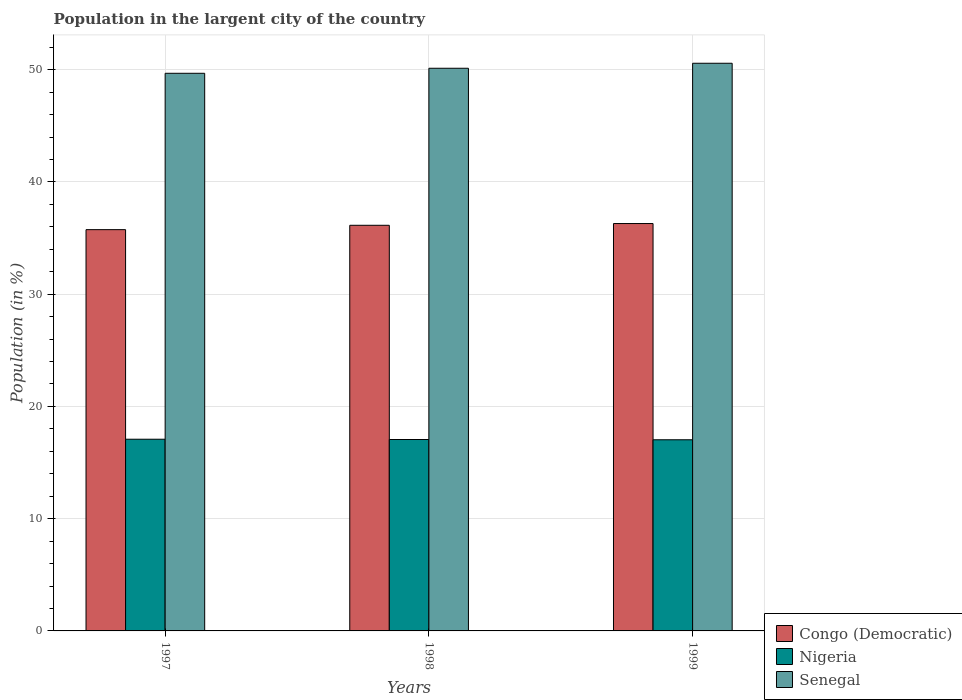Are the number of bars on each tick of the X-axis equal?
Offer a terse response. Yes. How many bars are there on the 3rd tick from the left?
Provide a short and direct response. 3. How many bars are there on the 3rd tick from the right?
Your answer should be compact. 3. What is the label of the 2nd group of bars from the left?
Ensure brevity in your answer.  1998. In how many cases, is the number of bars for a given year not equal to the number of legend labels?
Offer a very short reply. 0. What is the percentage of population in the largent city in Congo (Democratic) in 1997?
Offer a terse response. 35.75. Across all years, what is the maximum percentage of population in the largent city in Congo (Democratic)?
Make the answer very short. 36.29. Across all years, what is the minimum percentage of population in the largent city in Nigeria?
Give a very brief answer. 17.03. In which year was the percentage of population in the largent city in Senegal maximum?
Provide a succinct answer. 1999. In which year was the percentage of population in the largent city in Senegal minimum?
Offer a terse response. 1997. What is the total percentage of population in the largent city in Senegal in the graph?
Give a very brief answer. 150.38. What is the difference between the percentage of population in the largent city in Nigeria in 1998 and that in 1999?
Your answer should be very brief. 0.02. What is the difference between the percentage of population in the largent city in Senegal in 1998 and the percentage of population in the largent city in Congo (Democratic) in 1997?
Ensure brevity in your answer.  14.38. What is the average percentage of population in the largent city in Nigeria per year?
Make the answer very short. 17.05. In the year 1998, what is the difference between the percentage of population in the largent city in Nigeria and percentage of population in the largent city in Senegal?
Your response must be concise. -33.07. What is the ratio of the percentage of population in the largent city in Nigeria in 1997 to that in 1999?
Your response must be concise. 1. Is the difference between the percentage of population in the largent city in Nigeria in 1997 and 1998 greater than the difference between the percentage of population in the largent city in Senegal in 1997 and 1998?
Offer a very short reply. Yes. What is the difference between the highest and the second highest percentage of population in the largent city in Nigeria?
Your response must be concise. 0.02. What is the difference between the highest and the lowest percentage of population in the largent city in Senegal?
Keep it short and to the point. 0.89. Is the sum of the percentage of population in the largent city in Senegal in 1997 and 1998 greater than the maximum percentage of population in the largent city in Nigeria across all years?
Provide a succinct answer. Yes. What does the 3rd bar from the left in 1999 represents?
Your answer should be compact. Senegal. What does the 1st bar from the right in 1998 represents?
Your answer should be compact. Senegal. How many bars are there?
Provide a short and direct response. 9. How many years are there in the graph?
Keep it short and to the point. 3. Does the graph contain any zero values?
Your answer should be compact. No. Where does the legend appear in the graph?
Your response must be concise. Bottom right. How are the legend labels stacked?
Offer a terse response. Vertical. What is the title of the graph?
Give a very brief answer. Population in the largent city of the country. What is the Population (in %) of Congo (Democratic) in 1997?
Provide a succinct answer. 35.75. What is the Population (in %) in Nigeria in 1997?
Your answer should be very brief. 17.08. What is the Population (in %) in Senegal in 1997?
Make the answer very short. 49.68. What is the Population (in %) of Congo (Democratic) in 1998?
Ensure brevity in your answer.  36.14. What is the Population (in %) of Nigeria in 1998?
Make the answer very short. 17.05. What is the Population (in %) of Senegal in 1998?
Offer a very short reply. 50.13. What is the Population (in %) of Congo (Democratic) in 1999?
Provide a short and direct response. 36.29. What is the Population (in %) in Nigeria in 1999?
Provide a succinct answer. 17.03. What is the Population (in %) in Senegal in 1999?
Give a very brief answer. 50.57. Across all years, what is the maximum Population (in %) of Congo (Democratic)?
Make the answer very short. 36.29. Across all years, what is the maximum Population (in %) in Nigeria?
Make the answer very short. 17.08. Across all years, what is the maximum Population (in %) in Senegal?
Keep it short and to the point. 50.57. Across all years, what is the minimum Population (in %) in Congo (Democratic)?
Give a very brief answer. 35.75. Across all years, what is the minimum Population (in %) in Nigeria?
Your response must be concise. 17.03. Across all years, what is the minimum Population (in %) in Senegal?
Your answer should be compact. 49.68. What is the total Population (in %) in Congo (Democratic) in the graph?
Offer a terse response. 108.18. What is the total Population (in %) in Nigeria in the graph?
Give a very brief answer. 51.16. What is the total Population (in %) in Senegal in the graph?
Your response must be concise. 150.38. What is the difference between the Population (in %) of Congo (Democratic) in 1997 and that in 1998?
Make the answer very short. -0.39. What is the difference between the Population (in %) in Nigeria in 1997 and that in 1998?
Offer a terse response. 0.02. What is the difference between the Population (in %) in Senegal in 1997 and that in 1998?
Provide a short and direct response. -0.45. What is the difference between the Population (in %) in Congo (Democratic) in 1997 and that in 1999?
Provide a short and direct response. -0.54. What is the difference between the Population (in %) of Nigeria in 1997 and that in 1999?
Make the answer very short. 0.05. What is the difference between the Population (in %) in Senegal in 1997 and that in 1999?
Provide a short and direct response. -0.89. What is the difference between the Population (in %) of Congo (Democratic) in 1998 and that in 1999?
Your answer should be compact. -0.16. What is the difference between the Population (in %) in Nigeria in 1998 and that in 1999?
Provide a succinct answer. 0.02. What is the difference between the Population (in %) in Senegal in 1998 and that in 1999?
Provide a short and direct response. -0.45. What is the difference between the Population (in %) of Congo (Democratic) in 1997 and the Population (in %) of Nigeria in 1998?
Make the answer very short. 18.7. What is the difference between the Population (in %) of Congo (Democratic) in 1997 and the Population (in %) of Senegal in 1998?
Your answer should be compact. -14.38. What is the difference between the Population (in %) in Nigeria in 1997 and the Population (in %) in Senegal in 1998?
Offer a terse response. -33.05. What is the difference between the Population (in %) of Congo (Democratic) in 1997 and the Population (in %) of Nigeria in 1999?
Make the answer very short. 18.72. What is the difference between the Population (in %) of Congo (Democratic) in 1997 and the Population (in %) of Senegal in 1999?
Your response must be concise. -14.82. What is the difference between the Population (in %) in Nigeria in 1997 and the Population (in %) in Senegal in 1999?
Make the answer very short. -33.49. What is the difference between the Population (in %) of Congo (Democratic) in 1998 and the Population (in %) of Nigeria in 1999?
Provide a succinct answer. 19.11. What is the difference between the Population (in %) in Congo (Democratic) in 1998 and the Population (in %) in Senegal in 1999?
Ensure brevity in your answer.  -14.44. What is the difference between the Population (in %) of Nigeria in 1998 and the Population (in %) of Senegal in 1999?
Offer a very short reply. -33.52. What is the average Population (in %) of Congo (Democratic) per year?
Provide a succinct answer. 36.06. What is the average Population (in %) in Nigeria per year?
Provide a succinct answer. 17.05. What is the average Population (in %) of Senegal per year?
Offer a terse response. 50.13. In the year 1997, what is the difference between the Population (in %) in Congo (Democratic) and Population (in %) in Nigeria?
Keep it short and to the point. 18.67. In the year 1997, what is the difference between the Population (in %) in Congo (Democratic) and Population (in %) in Senegal?
Give a very brief answer. -13.93. In the year 1997, what is the difference between the Population (in %) in Nigeria and Population (in %) in Senegal?
Provide a succinct answer. -32.6. In the year 1998, what is the difference between the Population (in %) in Congo (Democratic) and Population (in %) in Nigeria?
Keep it short and to the point. 19.08. In the year 1998, what is the difference between the Population (in %) in Congo (Democratic) and Population (in %) in Senegal?
Your answer should be compact. -13.99. In the year 1998, what is the difference between the Population (in %) of Nigeria and Population (in %) of Senegal?
Your answer should be compact. -33.07. In the year 1999, what is the difference between the Population (in %) of Congo (Democratic) and Population (in %) of Nigeria?
Give a very brief answer. 19.26. In the year 1999, what is the difference between the Population (in %) of Congo (Democratic) and Population (in %) of Senegal?
Provide a short and direct response. -14.28. In the year 1999, what is the difference between the Population (in %) in Nigeria and Population (in %) in Senegal?
Your answer should be compact. -33.54. What is the ratio of the Population (in %) of Congo (Democratic) in 1997 to that in 1998?
Keep it short and to the point. 0.99. What is the ratio of the Population (in %) of Congo (Democratic) in 1997 to that in 1999?
Your answer should be compact. 0.98. What is the ratio of the Population (in %) of Senegal in 1997 to that in 1999?
Your answer should be compact. 0.98. What is the ratio of the Population (in %) in Senegal in 1998 to that in 1999?
Offer a very short reply. 0.99. What is the difference between the highest and the second highest Population (in %) in Congo (Democratic)?
Provide a succinct answer. 0.16. What is the difference between the highest and the second highest Population (in %) in Nigeria?
Offer a very short reply. 0.02. What is the difference between the highest and the second highest Population (in %) in Senegal?
Provide a succinct answer. 0.45. What is the difference between the highest and the lowest Population (in %) of Congo (Democratic)?
Your response must be concise. 0.54. What is the difference between the highest and the lowest Population (in %) in Nigeria?
Make the answer very short. 0.05. What is the difference between the highest and the lowest Population (in %) in Senegal?
Make the answer very short. 0.89. 